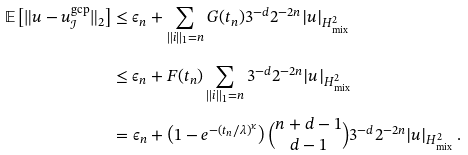<formula> <loc_0><loc_0><loc_500><loc_500>\mathbb { E } \left [ \| u - u ^ { \text {gcp} } _ { \mathcal { I } } \| _ { 2 } \right ] & \leq \epsilon _ { n } + \sum _ { \| i \| _ { 1 } = n } G ( t _ { n } ) 3 ^ { - d } 2 ^ { - 2 n } | u | _ { H ^ { 2 } _ { \text {mix} } } \\ & \leq \epsilon _ { n } + F ( t _ { n } ) \sum _ { \| i \| _ { 1 } = n } 3 ^ { - d } 2 ^ { - 2 n } | u | _ { H ^ { 2 } _ { \text {mix} } } \\ & = \epsilon _ { n } + \left ( 1 - e ^ { - ( t _ { n } / \lambda ) ^ { \kappa } } \right ) \binom { n + d - 1 } { d - 1 } 3 ^ { - d } 2 ^ { - 2 n } | u | _ { H ^ { 2 } _ { \text {mix} } } \, .</formula> 